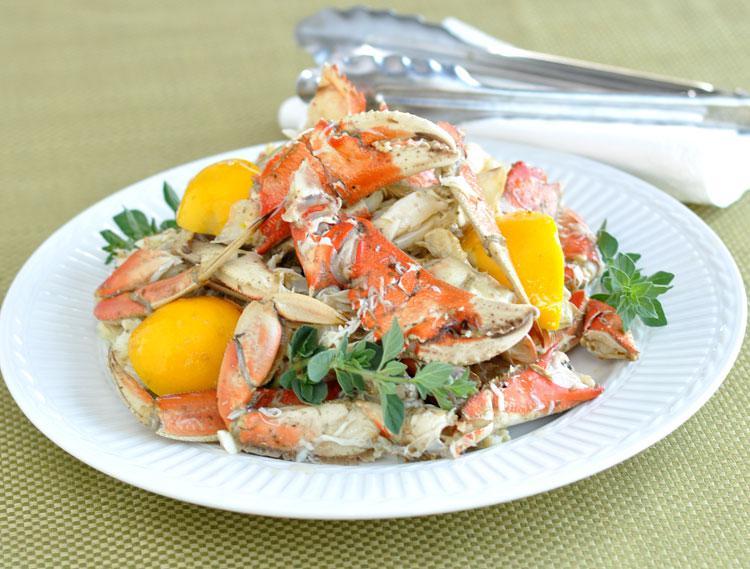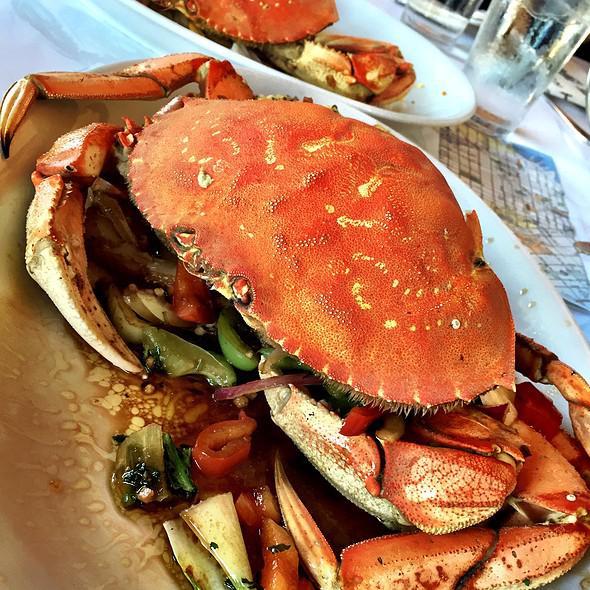The first image is the image on the left, the second image is the image on the right. Assess this claim about the two images: "In one image the entire crab is left intact, while the other image shows only pieces of a crab on a plate.". Correct or not? Answer yes or no. Yes. 